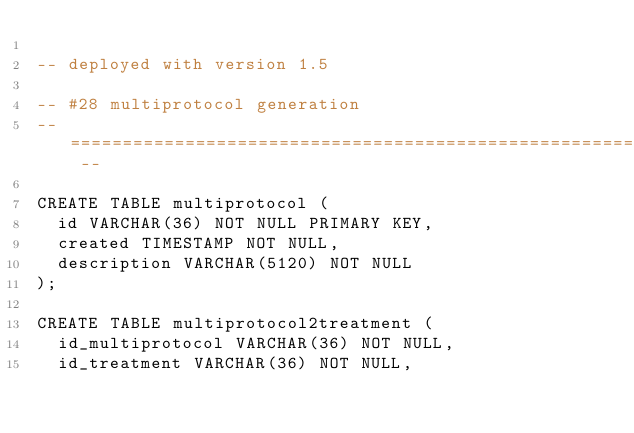Convert code to text. <code><loc_0><loc_0><loc_500><loc_500><_SQL_>
-- deployed with version 1.5

-- #28 multiprotocol generation
-- ========================================================================= --

CREATE TABLE multiprotocol (
  id VARCHAR(36) NOT NULL PRIMARY KEY,
  created TIMESTAMP NOT NULL,
  description VARCHAR(5120) NOT NULL
);

CREATE TABLE multiprotocol2treatment (
  id_multiprotocol VARCHAR(36) NOT NULL,
  id_treatment VARCHAR(36) NOT NULL,
</code> 